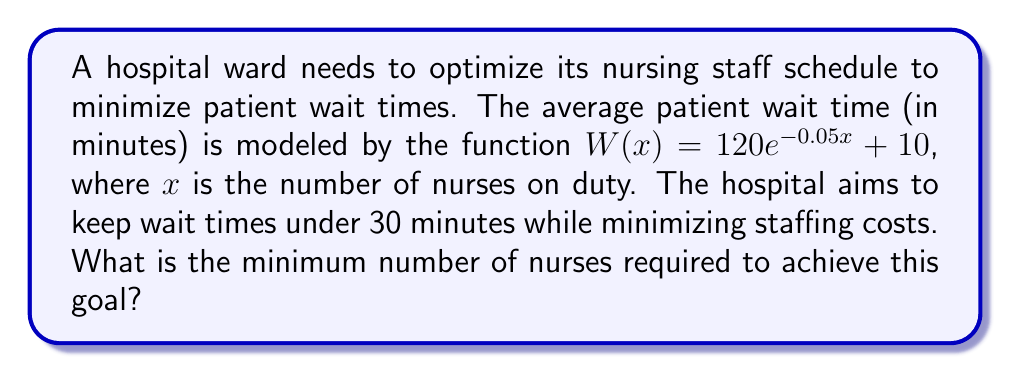Provide a solution to this math problem. To solve this problem, we need to follow these steps:

1) We want to find the value of $x$ where $W(x) = 30$ (the target wait time).

2) Set up the equation:
   $30 = 120e^{-0.05x} + 10$

3) Subtract 10 from both sides:
   $20 = 120e^{-0.05x}$

4) Divide both sides by 120:
   $\frac{1}{6} = e^{-0.05x}$

5) Take the natural logarithm of both sides:
   $\ln(\frac{1}{6}) = -0.05x$

6) Multiply both sides by -20:
   $-20\ln(\frac{1}{6}) = x$

7) Calculate the value:
   $x \approx 35.83$

8) Since we need a whole number of nurses and we're finding the minimum number required, we round up to the nearest integer.

Therefore, the minimum number of nurses required is 36.
Answer: 36 nurses 